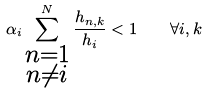Convert formula to latex. <formula><loc_0><loc_0><loc_500><loc_500>\alpha _ { i } \sum _ { \substack { n = 1 \\ n \neq i } } ^ { N } \frac { h _ { n , k } } { h _ { i } } < 1 \quad \forall i , k</formula> 